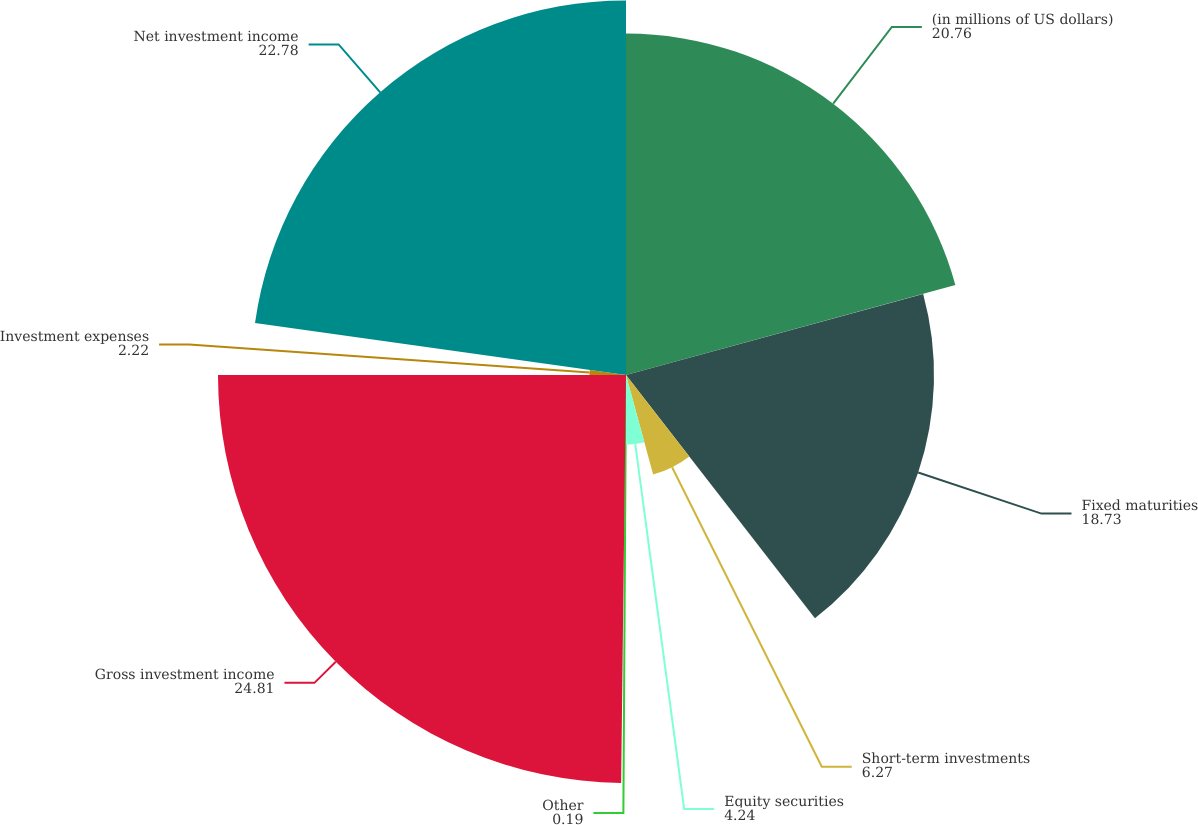Convert chart to OTSL. <chart><loc_0><loc_0><loc_500><loc_500><pie_chart><fcel>(in millions of US dollars)<fcel>Fixed maturities<fcel>Short-term investments<fcel>Equity securities<fcel>Other<fcel>Gross investment income<fcel>Investment expenses<fcel>Net investment income<nl><fcel>20.76%<fcel>18.73%<fcel>6.27%<fcel>4.24%<fcel>0.19%<fcel>24.81%<fcel>2.22%<fcel>22.78%<nl></chart> 